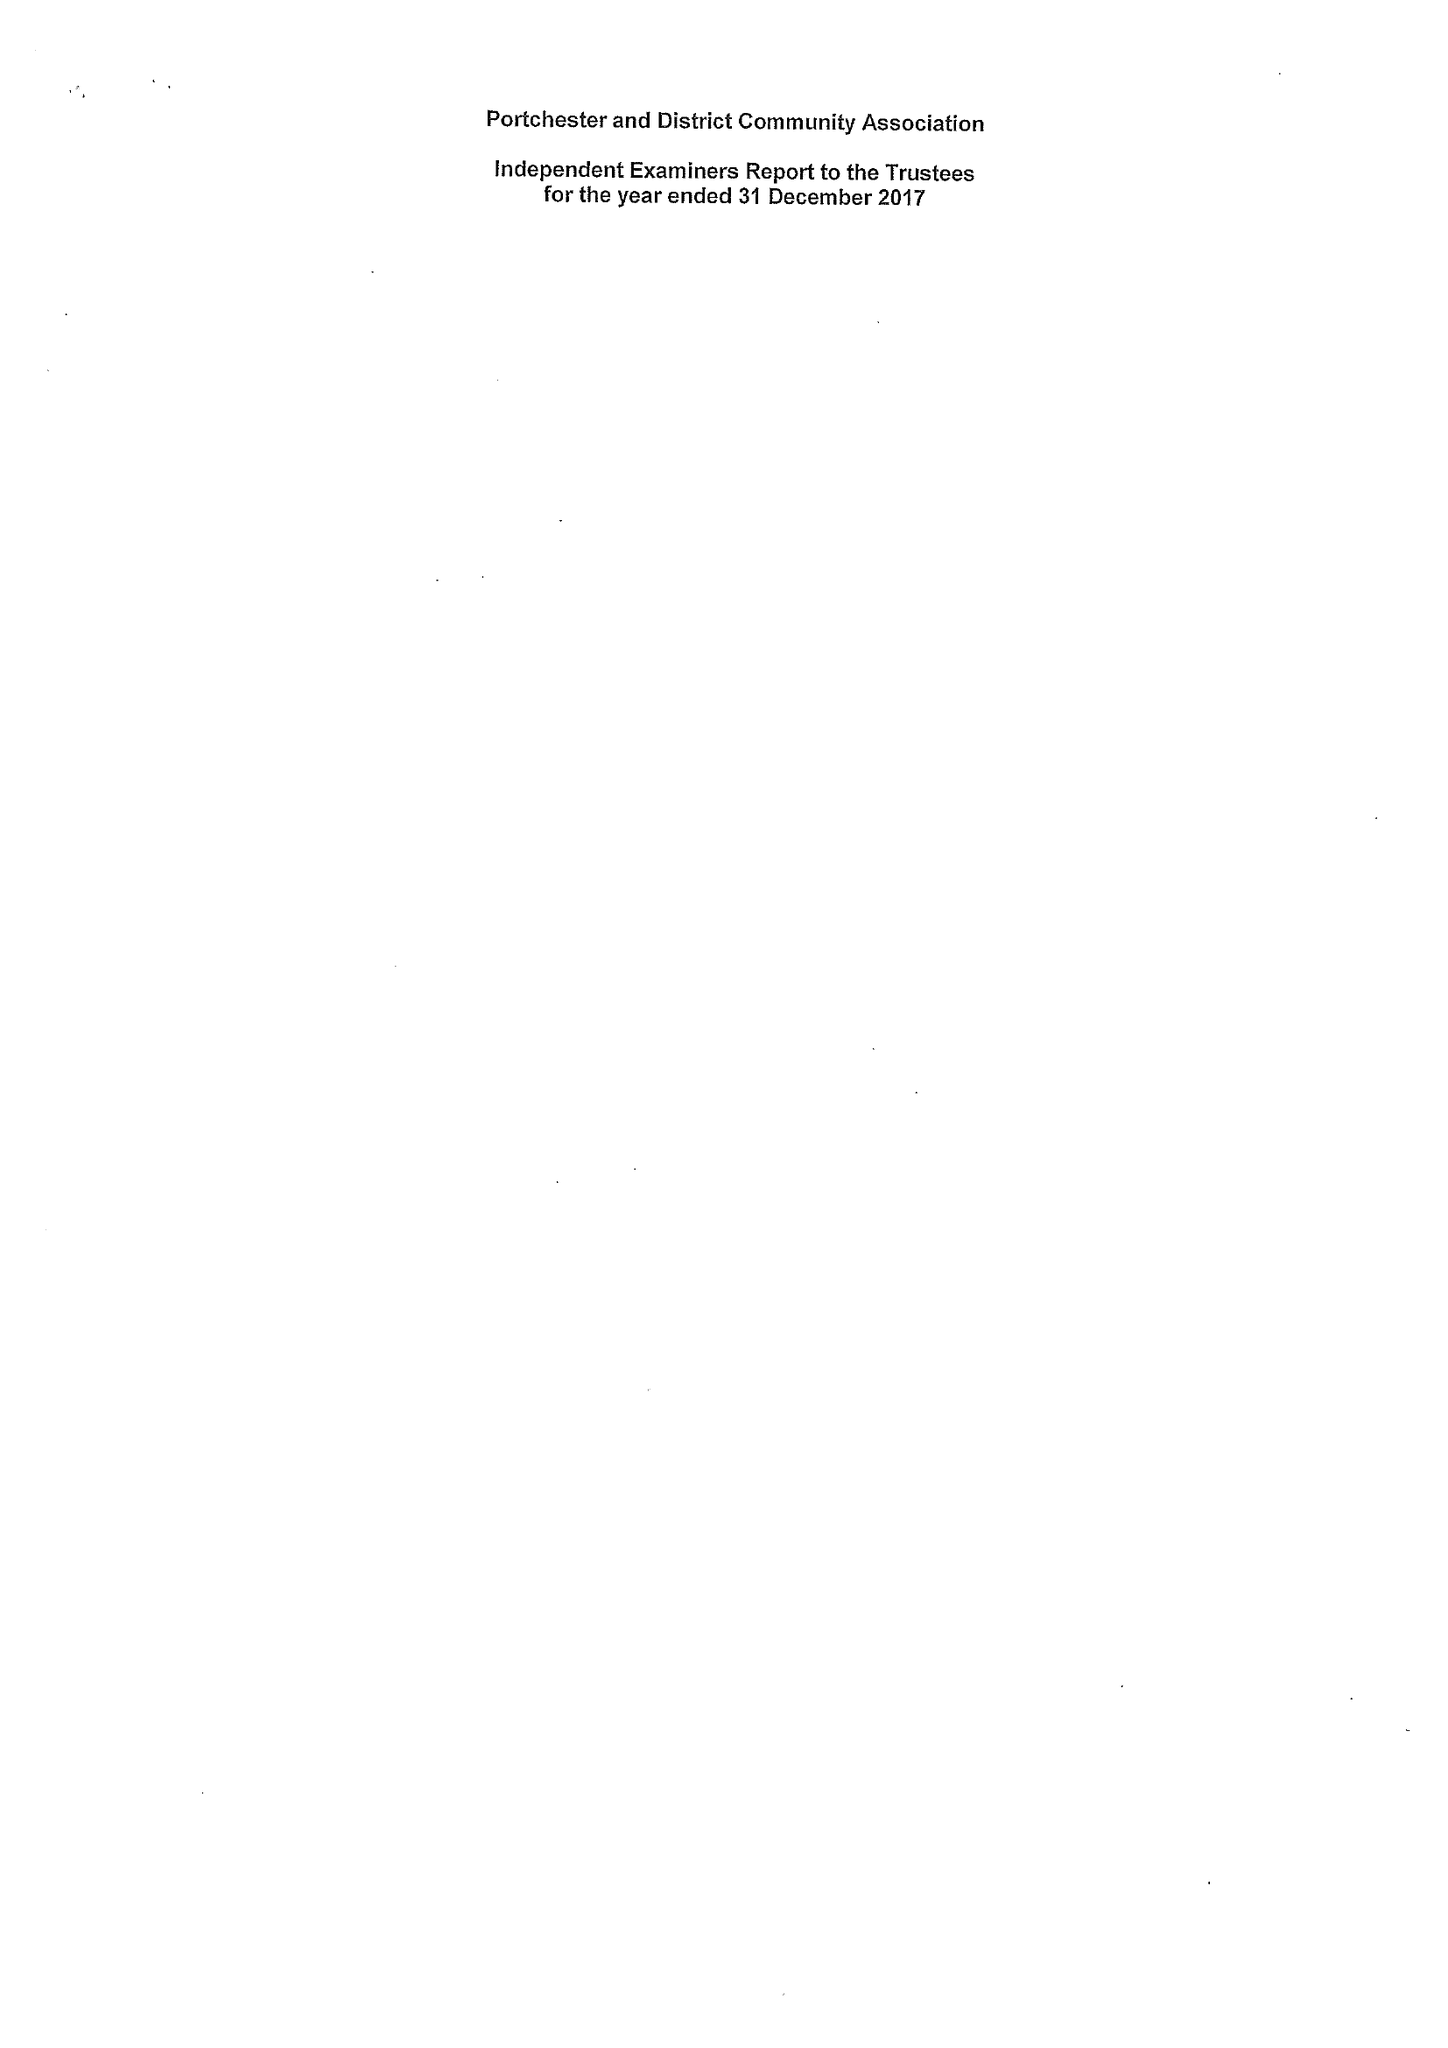What is the value for the address__street_line?
Answer the question using a single word or phrase. None 